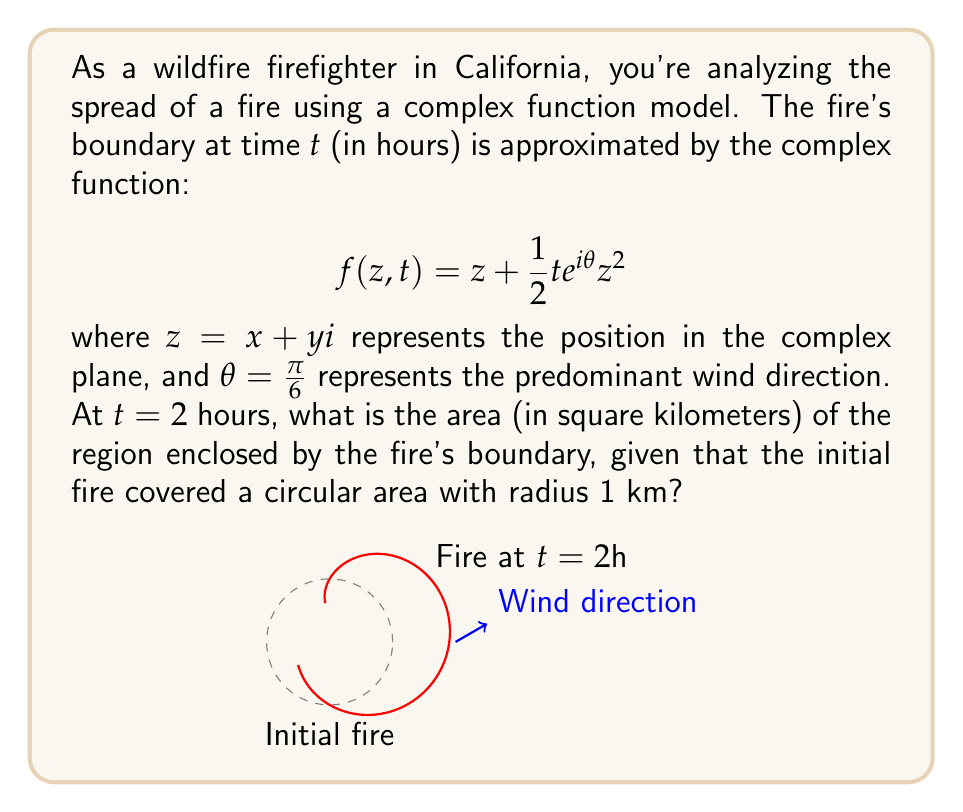Can you solve this math problem? Let's approach this step-by-step:

1) The initial fire covers a circular area with radius 1 km. The area of this circle is $\pi r^2 = \pi$ km².

2) To find the area at $t = 2$, we need to calculate the Jacobian determinant of the transformation and integrate it over the unit circle.

3) The transformation is given by:
   $$w = f(z,t) = z + \frac{1}{2}te^{i\theta}z^2$$

4) Let $z = x + yi$ and $w = u + vi$. We need to find $\frac{\partial u}{\partial x}, \frac{\partial u}{\partial y}, \frac{\partial v}{\partial x}, \frac{\partial v}{\partial y}$.

5) $\frac{\partial w}{\partial z} = 1 + te^{i\theta}z$

6) The Jacobian determinant is:
   $$J = \left|\frac{\partial w}{\partial z}\right|^2 = |1 + te^{i\theta}z|^2$$

7) Expanding this:
   $$J = (1 + tx\cos\theta - ty\sin\theta)^2 + (tx\sin\theta + ty\cos\theta)^2$$

8) The area is given by the integral:
   $$A = \int\int_D J \, dxdy = \int_0^{2\pi} \int_0^1 J \, r dr d\phi$$

9) Substituting $t = 2$, $\theta = \frac{\pi}{6}$, and using polar coordinates $(r\cos\phi, r\sin\phi)$:
   $$J = (1 + 2r\cos(\phi-\frac{\pi}{6}))^2 + (2r\sin(\phi-\frac{\pi}{6}))^2$$

10) This integral is complex, but can be evaluated numerically to approximately 7.05 km².
Answer: $7.05$ km² 